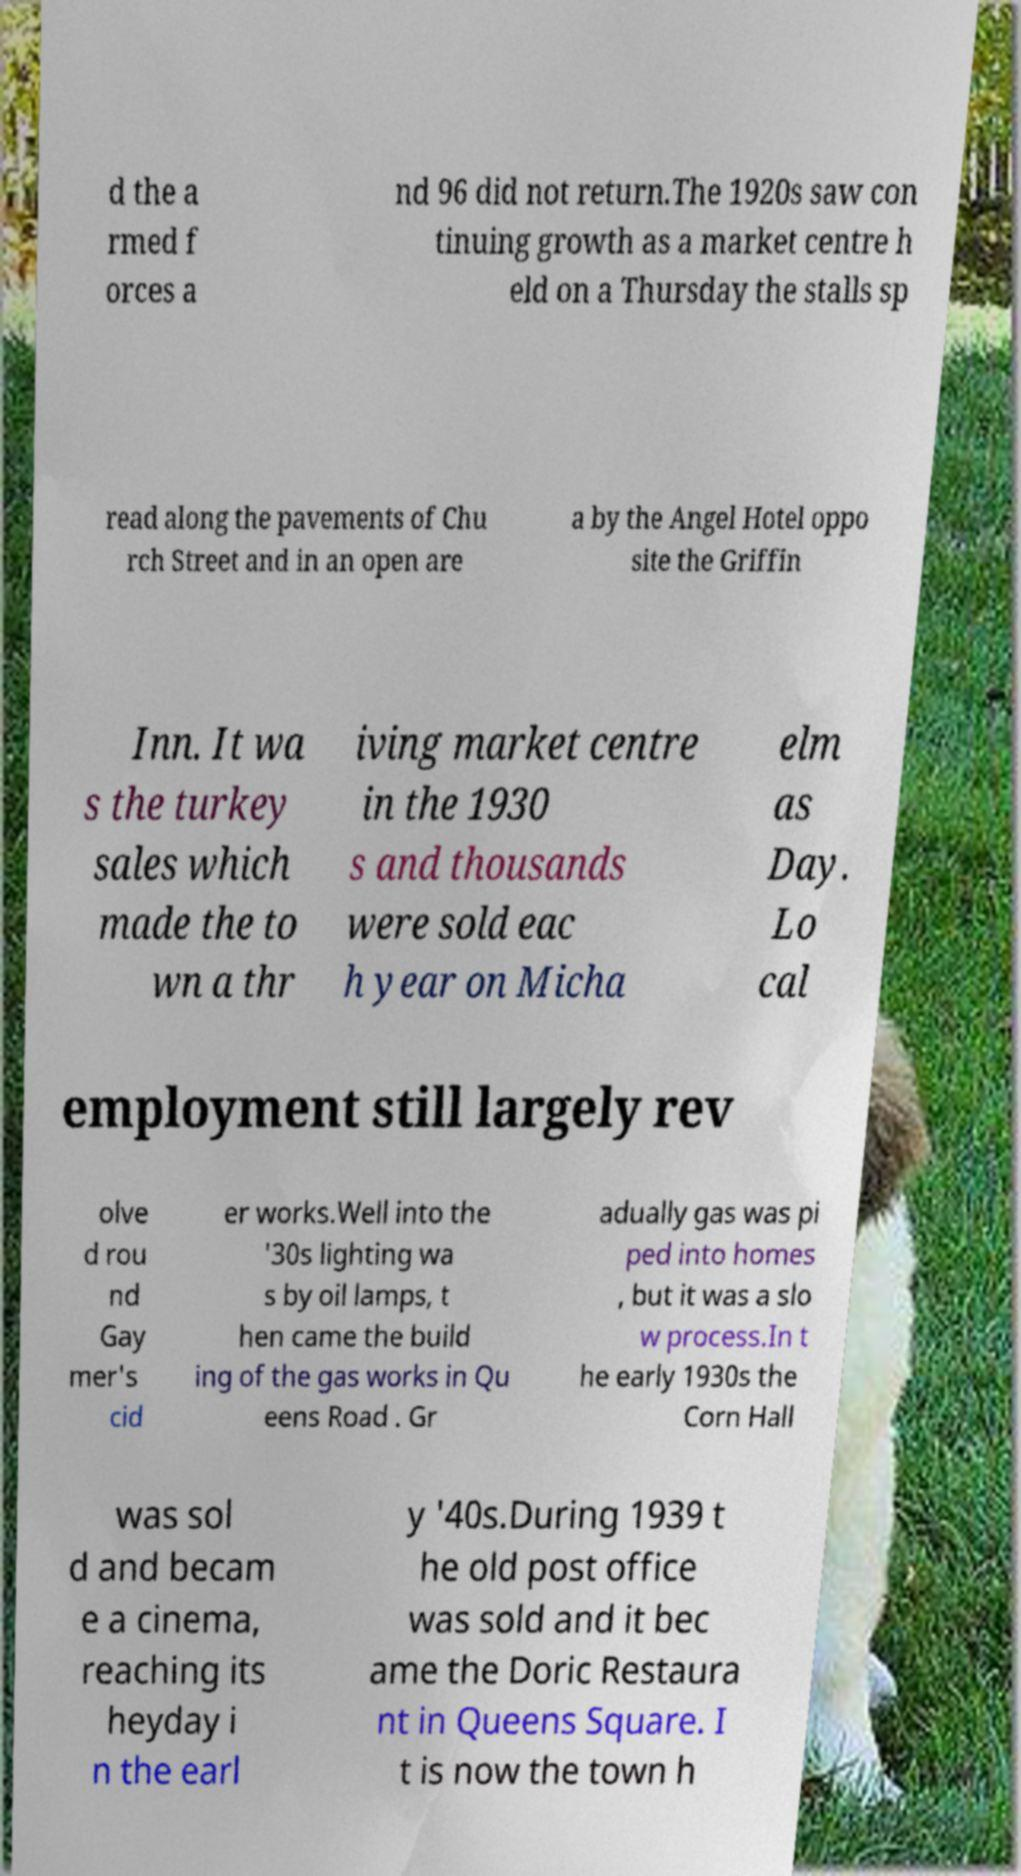Could you assist in decoding the text presented in this image and type it out clearly? d the a rmed f orces a nd 96 did not return.The 1920s saw con tinuing growth as a market centre h eld on a Thursday the stalls sp read along the pavements of Chu rch Street and in an open are a by the Angel Hotel oppo site the Griffin Inn. It wa s the turkey sales which made the to wn a thr iving market centre in the 1930 s and thousands were sold eac h year on Micha elm as Day. Lo cal employment still largely rev olve d rou nd Gay mer's cid er works.Well into the '30s lighting wa s by oil lamps, t hen came the build ing of the gas works in Qu eens Road . Gr adually gas was pi ped into homes , but it was a slo w process.In t he early 1930s the Corn Hall was sol d and becam e a cinema, reaching its heyday i n the earl y '40s.During 1939 t he old post office was sold and it bec ame the Doric Restaura nt in Queens Square. I t is now the town h 